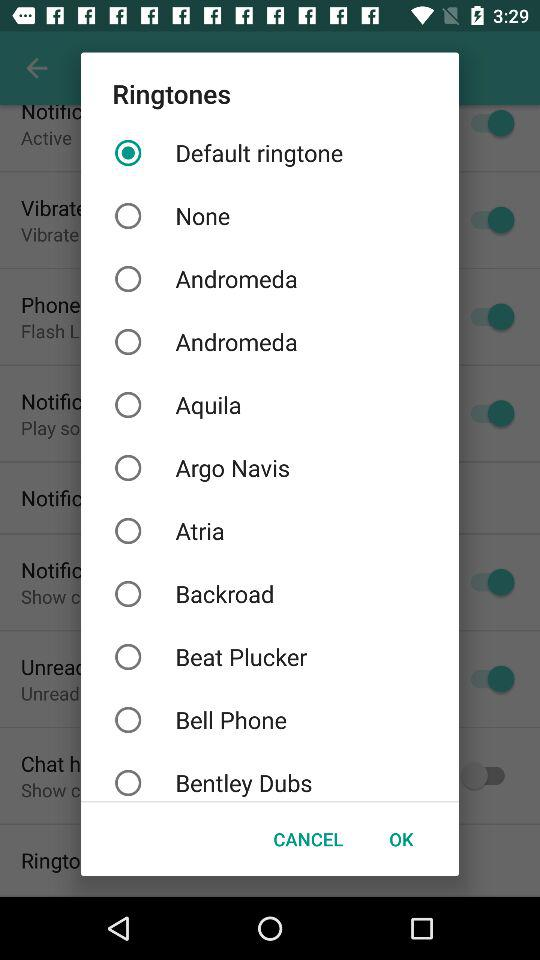Which is the selected ringtone? The selected ringtone is "Default ringtone". 